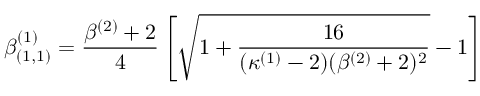Convert formula to latex. <formula><loc_0><loc_0><loc_500><loc_500>\beta _ { ( 1 , 1 ) } ^ { ( 1 ) } = \frac { \beta ^ { ( 2 ) } + 2 } { 4 } \left [ \sqrt { 1 + \frac { 1 6 } { ( \kappa ^ { ( 1 ) } - 2 ) ( \beta ^ { ( 2 ) } + 2 ) ^ { 2 } } } - 1 \right ]</formula> 